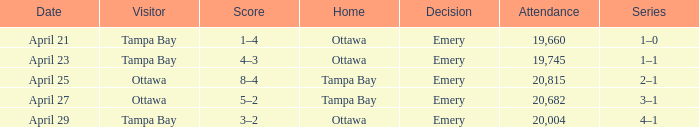What is the date of the game when attendance is more than 20,682? April 25. Could you parse the entire table as a dict? {'header': ['Date', 'Visitor', 'Score', 'Home', 'Decision', 'Attendance', 'Series'], 'rows': [['April 21', 'Tampa Bay', '1–4', 'Ottawa', 'Emery', '19,660', '1–0'], ['April 23', 'Tampa Bay', '4–3', 'Ottawa', 'Emery', '19,745', '1–1'], ['April 25', 'Ottawa', '8–4', 'Tampa Bay', 'Emery', '20,815', '2–1'], ['April 27', 'Ottawa', '5–2', 'Tampa Bay', 'Emery', '20,682', '3–1'], ['April 29', 'Tampa Bay', '3–2', 'Ottawa', 'Emery', '20,004', '4–1']]} 